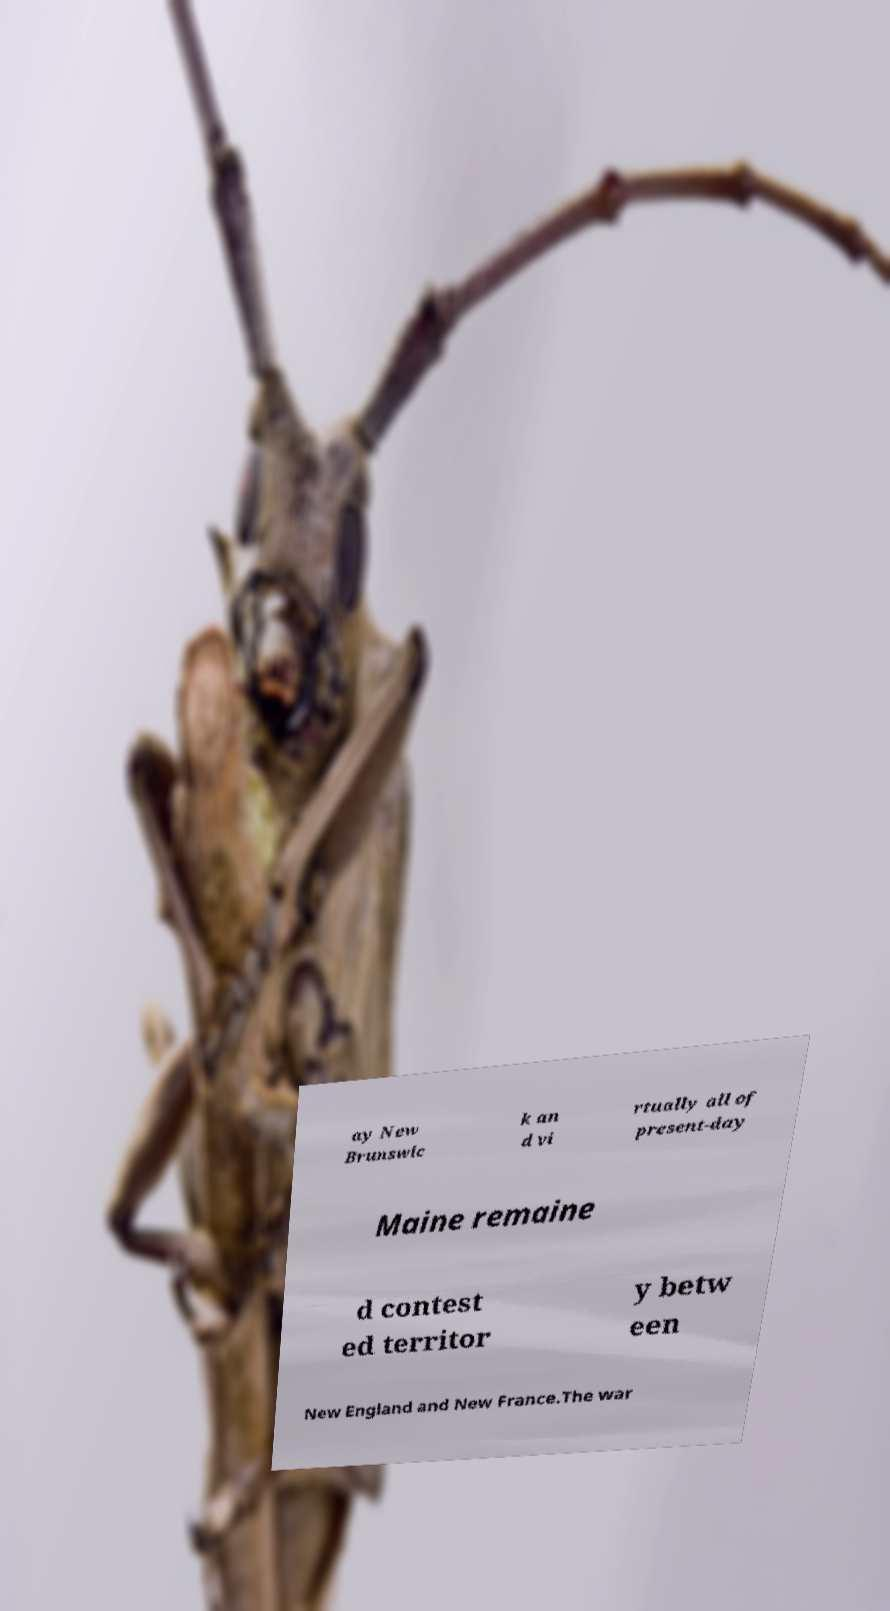Can you accurately transcribe the text from the provided image for me? ay New Brunswic k an d vi rtually all of present-day Maine remaine d contest ed territor y betw een New England and New France.The war 